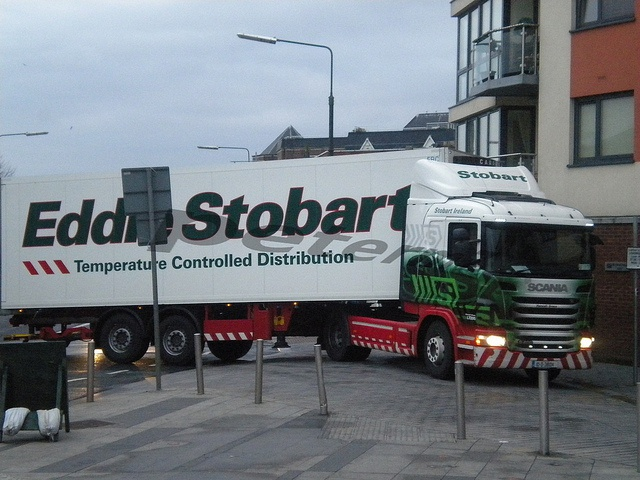Describe the objects in this image and their specific colors. I can see a truck in lightgray, black, and darkgray tones in this image. 